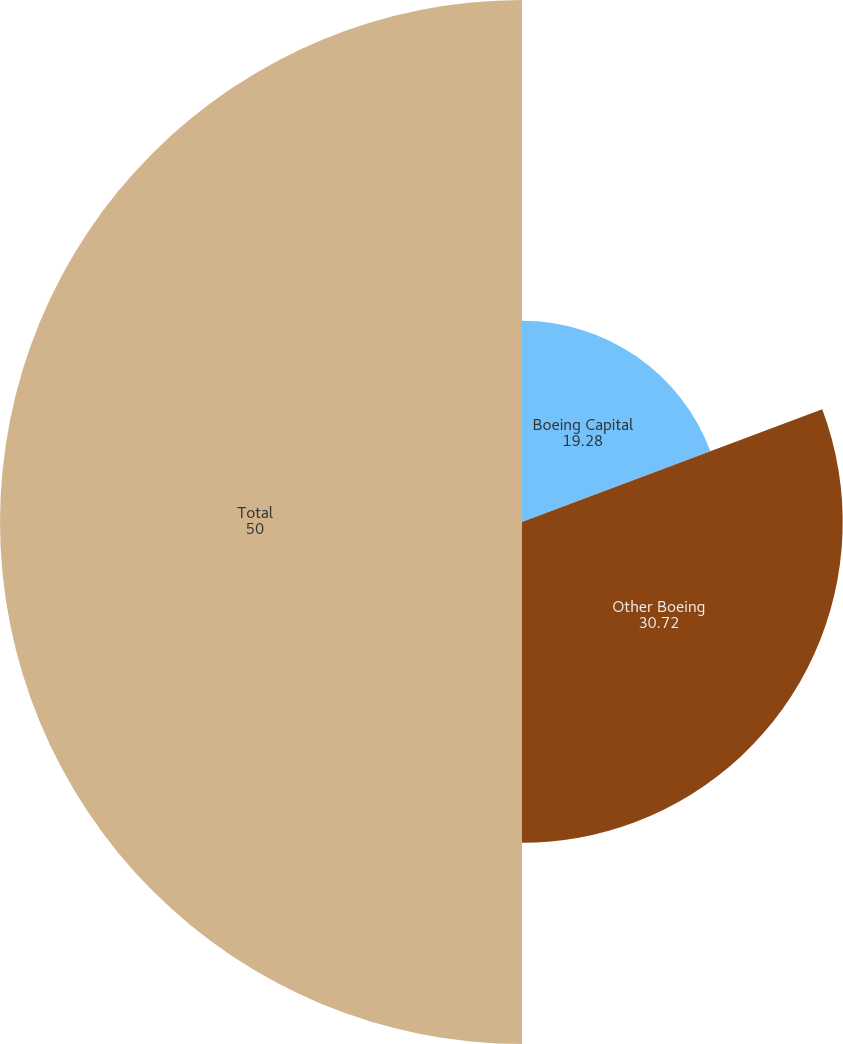Convert chart. <chart><loc_0><loc_0><loc_500><loc_500><pie_chart><fcel>Boeing Capital<fcel>Other Boeing<fcel>Total<nl><fcel>19.28%<fcel>30.72%<fcel>50.0%<nl></chart> 